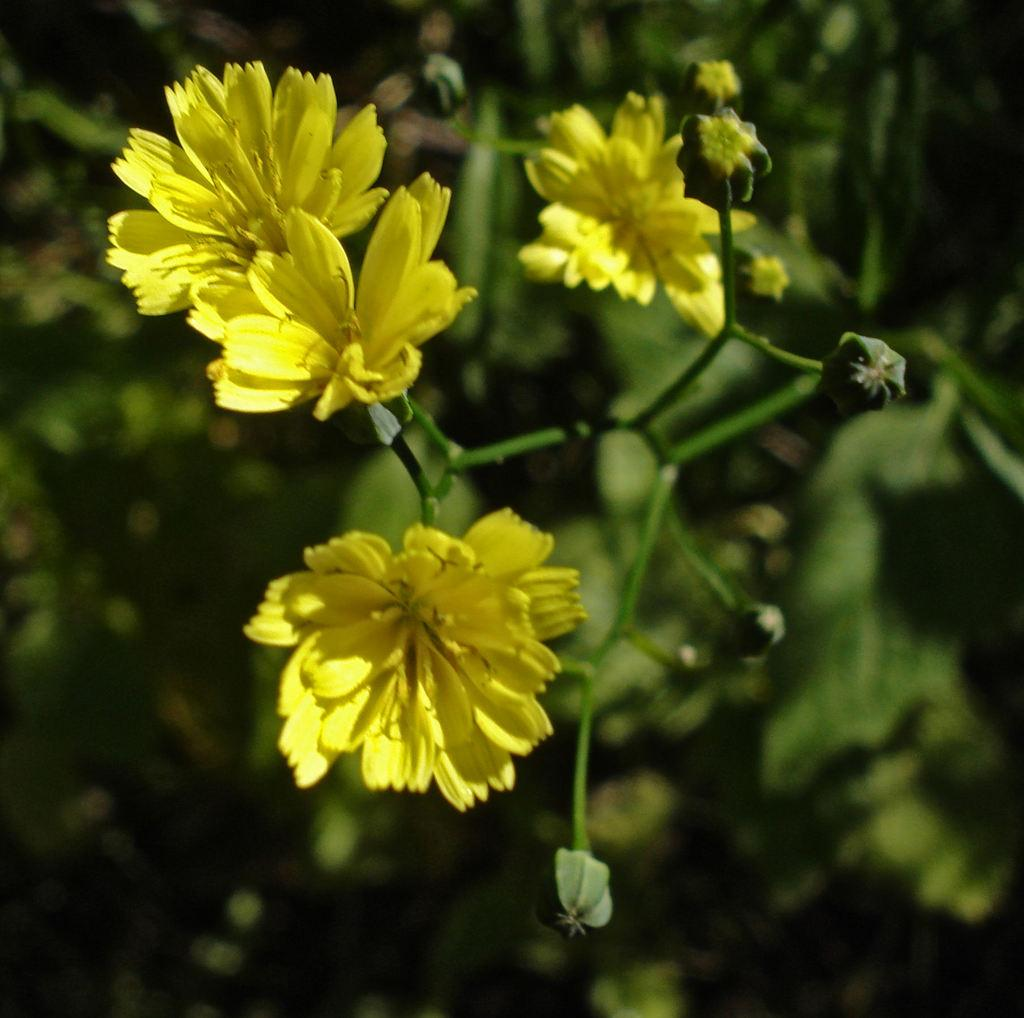What type of vegetation is present in the front of the image? There are plants in the front of the image. Can you describe the flowers in the image? There are yellow flowers in the image. What can be observed about the background of the image? The background of the image is blurred. How many cows are visible in the image? There are no cows present in the image. What type of tools does the carpenter use in the image? There is no carpenter or tools present in the image. 